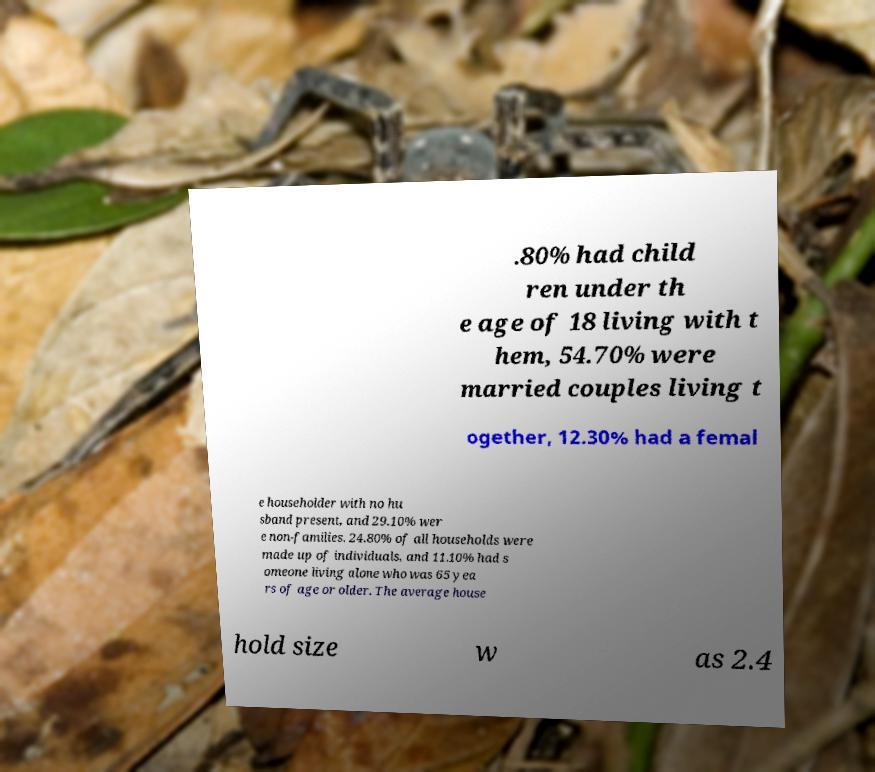There's text embedded in this image that I need extracted. Can you transcribe it verbatim? .80% had child ren under th e age of 18 living with t hem, 54.70% were married couples living t ogether, 12.30% had a femal e householder with no hu sband present, and 29.10% wer e non-families. 24.80% of all households were made up of individuals, and 11.10% had s omeone living alone who was 65 yea rs of age or older. The average house hold size w as 2.4 